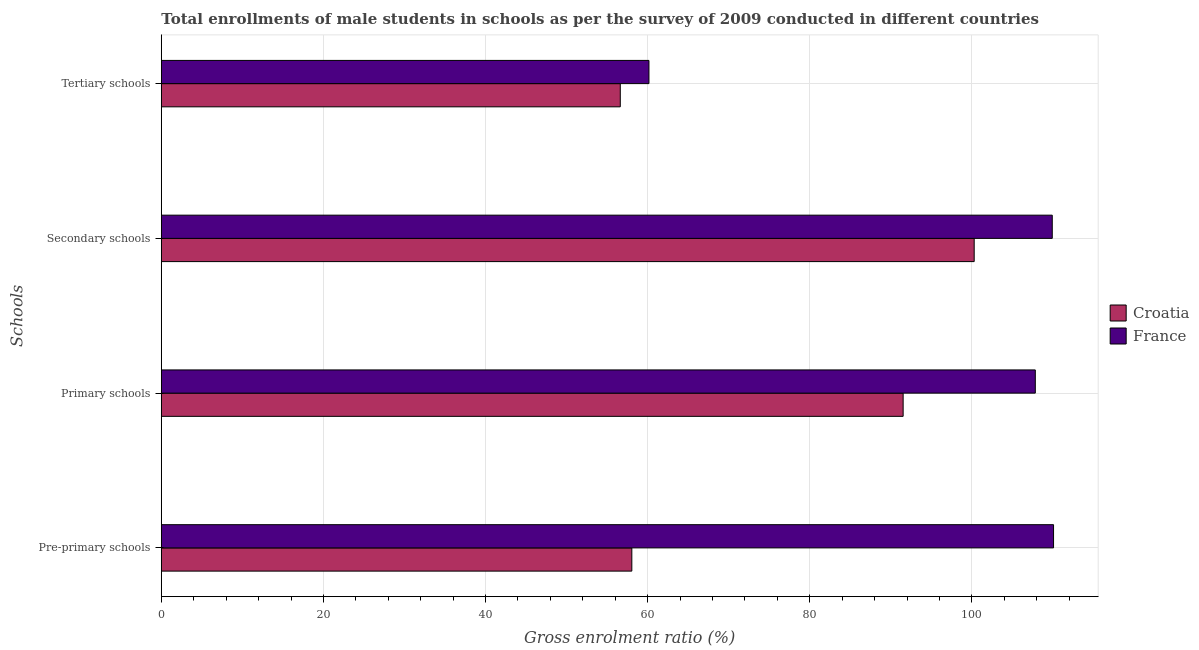Are the number of bars on each tick of the Y-axis equal?
Offer a terse response. Yes. What is the label of the 1st group of bars from the top?
Your answer should be compact. Tertiary schools. What is the gross enrolment ratio(male) in tertiary schools in France?
Keep it short and to the point. 60.16. Across all countries, what is the maximum gross enrolment ratio(male) in secondary schools?
Provide a succinct answer. 109.92. Across all countries, what is the minimum gross enrolment ratio(male) in pre-primary schools?
Offer a very short reply. 58.05. In which country was the gross enrolment ratio(male) in primary schools maximum?
Make the answer very short. France. In which country was the gross enrolment ratio(male) in tertiary schools minimum?
Offer a terse response. Croatia. What is the total gross enrolment ratio(male) in secondary schools in the graph?
Ensure brevity in your answer.  210.21. What is the difference between the gross enrolment ratio(male) in primary schools in France and that in Croatia?
Provide a succinct answer. 16.31. What is the difference between the gross enrolment ratio(male) in primary schools in France and the gross enrolment ratio(male) in secondary schools in Croatia?
Your answer should be compact. 7.54. What is the average gross enrolment ratio(male) in secondary schools per country?
Your answer should be very brief. 105.1. What is the difference between the gross enrolment ratio(male) in tertiary schools and gross enrolment ratio(male) in primary schools in Croatia?
Provide a short and direct response. -34.9. In how many countries, is the gross enrolment ratio(male) in pre-primary schools greater than 104 %?
Make the answer very short. 1. What is the ratio of the gross enrolment ratio(male) in primary schools in France to that in Croatia?
Provide a succinct answer. 1.18. What is the difference between the highest and the second highest gross enrolment ratio(male) in secondary schools?
Your response must be concise. 9.63. What is the difference between the highest and the lowest gross enrolment ratio(male) in primary schools?
Your response must be concise. 16.31. In how many countries, is the gross enrolment ratio(male) in secondary schools greater than the average gross enrolment ratio(male) in secondary schools taken over all countries?
Your response must be concise. 1. Is the sum of the gross enrolment ratio(male) in primary schools in Croatia and France greater than the maximum gross enrolment ratio(male) in tertiary schools across all countries?
Ensure brevity in your answer.  Yes. Is it the case that in every country, the sum of the gross enrolment ratio(male) in tertiary schools and gross enrolment ratio(male) in secondary schools is greater than the sum of gross enrolment ratio(male) in pre-primary schools and gross enrolment ratio(male) in primary schools?
Offer a terse response. No. What does the 2nd bar from the top in Pre-primary schools represents?
Your answer should be compact. Croatia. What does the 1st bar from the bottom in Primary schools represents?
Give a very brief answer. Croatia. Is it the case that in every country, the sum of the gross enrolment ratio(male) in pre-primary schools and gross enrolment ratio(male) in primary schools is greater than the gross enrolment ratio(male) in secondary schools?
Your answer should be very brief. Yes. How many bars are there?
Make the answer very short. 8. Are all the bars in the graph horizontal?
Provide a succinct answer. Yes. Are the values on the major ticks of X-axis written in scientific E-notation?
Your answer should be compact. No. Does the graph contain any zero values?
Your answer should be compact. No. Where does the legend appear in the graph?
Your response must be concise. Center right. How many legend labels are there?
Provide a short and direct response. 2. How are the legend labels stacked?
Your answer should be compact. Vertical. What is the title of the graph?
Make the answer very short. Total enrollments of male students in schools as per the survey of 2009 conducted in different countries. Does "Middle East & North Africa (all income levels)" appear as one of the legend labels in the graph?
Provide a short and direct response. No. What is the label or title of the X-axis?
Give a very brief answer. Gross enrolment ratio (%). What is the label or title of the Y-axis?
Make the answer very short. Schools. What is the Gross enrolment ratio (%) in Croatia in Pre-primary schools?
Keep it short and to the point. 58.05. What is the Gross enrolment ratio (%) in France in Pre-primary schools?
Your answer should be very brief. 110.08. What is the Gross enrolment ratio (%) of Croatia in Primary schools?
Your answer should be compact. 91.52. What is the Gross enrolment ratio (%) of France in Primary schools?
Your answer should be compact. 107.83. What is the Gross enrolment ratio (%) in Croatia in Secondary schools?
Provide a short and direct response. 100.29. What is the Gross enrolment ratio (%) in France in Secondary schools?
Provide a succinct answer. 109.92. What is the Gross enrolment ratio (%) in Croatia in Tertiary schools?
Offer a very short reply. 56.62. What is the Gross enrolment ratio (%) of France in Tertiary schools?
Give a very brief answer. 60.16. Across all Schools, what is the maximum Gross enrolment ratio (%) in Croatia?
Your response must be concise. 100.29. Across all Schools, what is the maximum Gross enrolment ratio (%) of France?
Your answer should be compact. 110.08. Across all Schools, what is the minimum Gross enrolment ratio (%) of Croatia?
Provide a succinct answer. 56.62. Across all Schools, what is the minimum Gross enrolment ratio (%) of France?
Your answer should be compact. 60.16. What is the total Gross enrolment ratio (%) in Croatia in the graph?
Ensure brevity in your answer.  306.48. What is the total Gross enrolment ratio (%) in France in the graph?
Keep it short and to the point. 387.99. What is the difference between the Gross enrolment ratio (%) of Croatia in Pre-primary schools and that in Primary schools?
Your answer should be compact. -33.47. What is the difference between the Gross enrolment ratio (%) in France in Pre-primary schools and that in Primary schools?
Make the answer very short. 2.25. What is the difference between the Gross enrolment ratio (%) in Croatia in Pre-primary schools and that in Secondary schools?
Make the answer very short. -42.24. What is the difference between the Gross enrolment ratio (%) of France in Pre-primary schools and that in Secondary schools?
Your response must be concise. 0.16. What is the difference between the Gross enrolment ratio (%) in Croatia in Pre-primary schools and that in Tertiary schools?
Offer a terse response. 1.43. What is the difference between the Gross enrolment ratio (%) of France in Pre-primary schools and that in Tertiary schools?
Keep it short and to the point. 49.92. What is the difference between the Gross enrolment ratio (%) in Croatia in Primary schools and that in Secondary schools?
Give a very brief answer. -8.77. What is the difference between the Gross enrolment ratio (%) of France in Primary schools and that in Secondary schools?
Make the answer very short. -2.09. What is the difference between the Gross enrolment ratio (%) in Croatia in Primary schools and that in Tertiary schools?
Your response must be concise. 34.9. What is the difference between the Gross enrolment ratio (%) in France in Primary schools and that in Tertiary schools?
Your response must be concise. 47.66. What is the difference between the Gross enrolment ratio (%) of Croatia in Secondary schools and that in Tertiary schools?
Offer a very short reply. 43.66. What is the difference between the Gross enrolment ratio (%) of France in Secondary schools and that in Tertiary schools?
Provide a succinct answer. 49.76. What is the difference between the Gross enrolment ratio (%) in Croatia in Pre-primary schools and the Gross enrolment ratio (%) in France in Primary schools?
Provide a short and direct response. -49.78. What is the difference between the Gross enrolment ratio (%) in Croatia in Pre-primary schools and the Gross enrolment ratio (%) in France in Secondary schools?
Provide a succinct answer. -51.87. What is the difference between the Gross enrolment ratio (%) of Croatia in Pre-primary schools and the Gross enrolment ratio (%) of France in Tertiary schools?
Keep it short and to the point. -2.11. What is the difference between the Gross enrolment ratio (%) of Croatia in Primary schools and the Gross enrolment ratio (%) of France in Secondary schools?
Your answer should be very brief. -18.4. What is the difference between the Gross enrolment ratio (%) in Croatia in Primary schools and the Gross enrolment ratio (%) in France in Tertiary schools?
Your response must be concise. 31.36. What is the difference between the Gross enrolment ratio (%) in Croatia in Secondary schools and the Gross enrolment ratio (%) in France in Tertiary schools?
Provide a succinct answer. 40.13. What is the average Gross enrolment ratio (%) of Croatia per Schools?
Provide a succinct answer. 76.62. What is the average Gross enrolment ratio (%) in France per Schools?
Ensure brevity in your answer.  97. What is the difference between the Gross enrolment ratio (%) of Croatia and Gross enrolment ratio (%) of France in Pre-primary schools?
Keep it short and to the point. -52.03. What is the difference between the Gross enrolment ratio (%) of Croatia and Gross enrolment ratio (%) of France in Primary schools?
Ensure brevity in your answer.  -16.31. What is the difference between the Gross enrolment ratio (%) in Croatia and Gross enrolment ratio (%) in France in Secondary schools?
Your response must be concise. -9.63. What is the difference between the Gross enrolment ratio (%) in Croatia and Gross enrolment ratio (%) in France in Tertiary schools?
Give a very brief answer. -3.54. What is the ratio of the Gross enrolment ratio (%) in Croatia in Pre-primary schools to that in Primary schools?
Your answer should be compact. 0.63. What is the ratio of the Gross enrolment ratio (%) of France in Pre-primary schools to that in Primary schools?
Provide a short and direct response. 1.02. What is the ratio of the Gross enrolment ratio (%) of Croatia in Pre-primary schools to that in Secondary schools?
Your answer should be very brief. 0.58. What is the ratio of the Gross enrolment ratio (%) in France in Pre-primary schools to that in Secondary schools?
Offer a terse response. 1. What is the ratio of the Gross enrolment ratio (%) in Croatia in Pre-primary schools to that in Tertiary schools?
Your response must be concise. 1.03. What is the ratio of the Gross enrolment ratio (%) of France in Pre-primary schools to that in Tertiary schools?
Your response must be concise. 1.83. What is the ratio of the Gross enrolment ratio (%) in Croatia in Primary schools to that in Secondary schools?
Keep it short and to the point. 0.91. What is the ratio of the Gross enrolment ratio (%) of France in Primary schools to that in Secondary schools?
Provide a short and direct response. 0.98. What is the ratio of the Gross enrolment ratio (%) in Croatia in Primary schools to that in Tertiary schools?
Your answer should be very brief. 1.62. What is the ratio of the Gross enrolment ratio (%) in France in Primary schools to that in Tertiary schools?
Provide a short and direct response. 1.79. What is the ratio of the Gross enrolment ratio (%) of Croatia in Secondary schools to that in Tertiary schools?
Provide a succinct answer. 1.77. What is the ratio of the Gross enrolment ratio (%) in France in Secondary schools to that in Tertiary schools?
Make the answer very short. 1.83. What is the difference between the highest and the second highest Gross enrolment ratio (%) in Croatia?
Your response must be concise. 8.77. What is the difference between the highest and the second highest Gross enrolment ratio (%) in France?
Provide a short and direct response. 0.16. What is the difference between the highest and the lowest Gross enrolment ratio (%) of Croatia?
Your response must be concise. 43.66. What is the difference between the highest and the lowest Gross enrolment ratio (%) of France?
Your response must be concise. 49.92. 